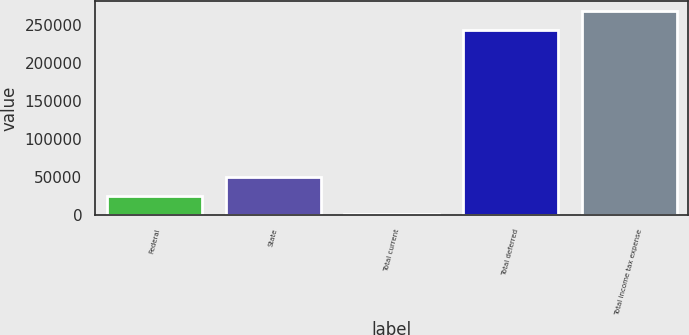<chart> <loc_0><loc_0><loc_500><loc_500><bar_chart><fcel>Federal<fcel>State<fcel>Total current<fcel>Total deferred<fcel>Total income tax expense<nl><fcel>25031.8<fcel>49405.6<fcel>658<fcel>243738<fcel>268112<nl></chart> 